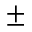Convert formula to latex. <formula><loc_0><loc_0><loc_500><loc_500>\pm</formula> 